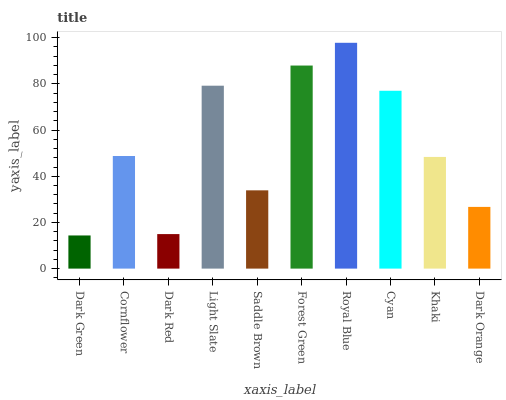Is Cornflower the minimum?
Answer yes or no. No. Is Cornflower the maximum?
Answer yes or no. No. Is Cornflower greater than Dark Green?
Answer yes or no. Yes. Is Dark Green less than Cornflower?
Answer yes or no. Yes. Is Dark Green greater than Cornflower?
Answer yes or no. No. Is Cornflower less than Dark Green?
Answer yes or no. No. Is Cornflower the high median?
Answer yes or no. Yes. Is Khaki the low median?
Answer yes or no. Yes. Is Cyan the high median?
Answer yes or no. No. Is Royal Blue the low median?
Answer yes or no. No. 